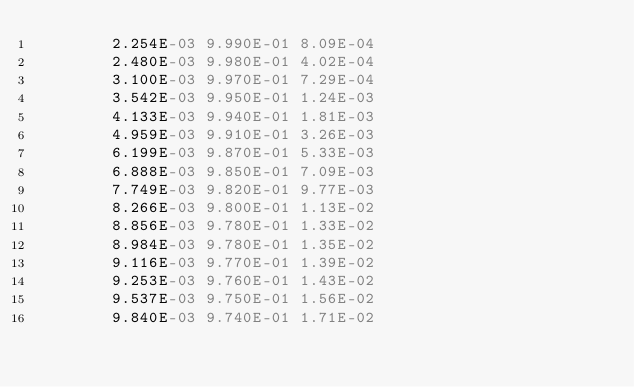Convert code to text. <code><loc_0><loc_0><loc_500><loc_500><_YAML_>        2.254E-03 9.990E-01 8.09E-04
        2.480E-03 9.980E-01 4.02E-04
        3.100E-03 9.970E-01 7.29E-04
        3.542E-03 9.950E-01 1.24E-03
        4.133E-03 9.940E-01 1.81E-03
        4.959E-03 9.910E-01 3.26E-03
        6.199E-03 9.870E-01 5.33E-03
        6.888E-03 9.850E-01 7.09E-03
        7.749E-03 9.820E-01 9.77E-03
        8.266E-03 9.800E-01 1.13E-02
        8.856E-03 9.780E-01 1.33E-02
        8.984E-03 9.780E-01 1.35E-02
        9.116E-03 9.770E-01 1.39E-02
        9.253E-03 9.760E-01 1.43E-02
        9.537E-03 9.750E-01 1.56E-02
        9.840E-03 9.740E-01 1.71E-02</code> 